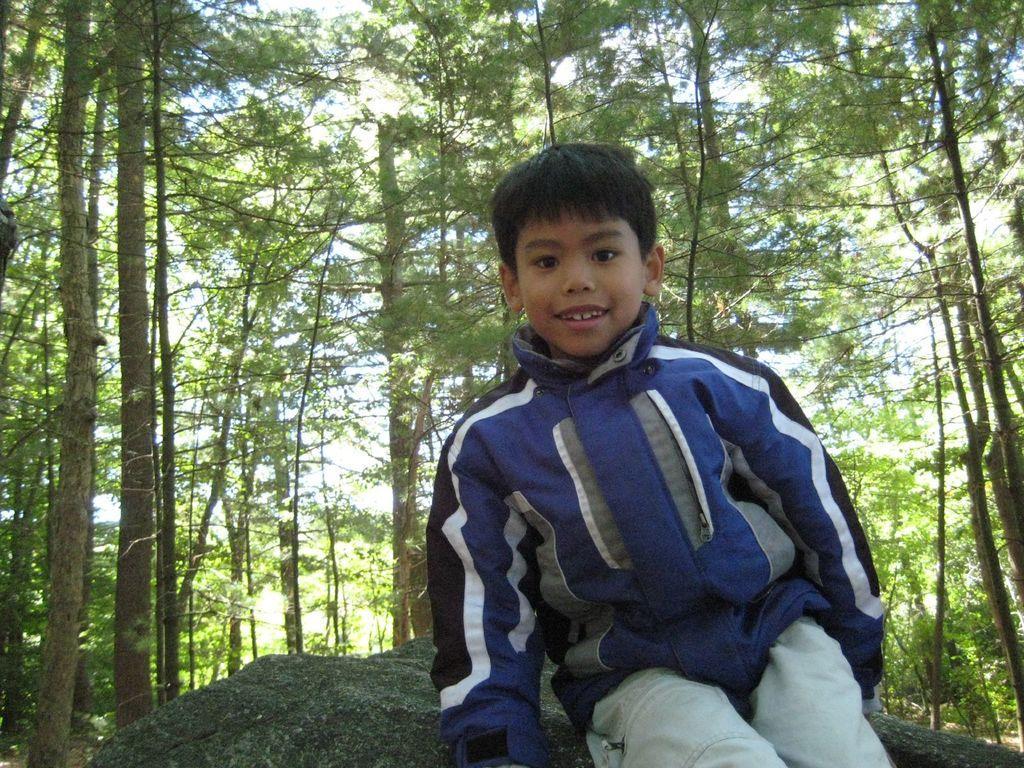Please provide a concise description of this image. In the picture we can see a boy sitting on the stone surface, he is wearing a blue color jacket and smiling and behind him we can see full of trees with tall branches. 